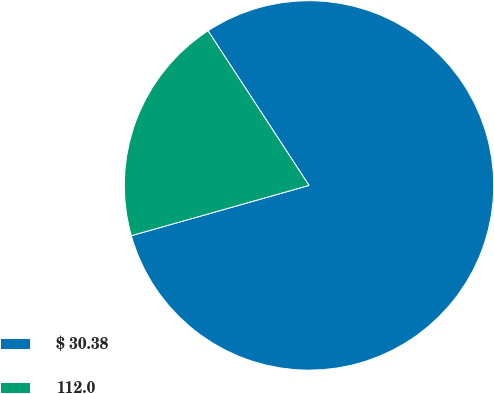Convert chart. <chart><loc_0><loc_0><loc_500><loc_500><pie_chart><fcel>$ 30.38<fcel>112.0<nl><fcel>79.82%<fcel>20.18%<nl></chart> 